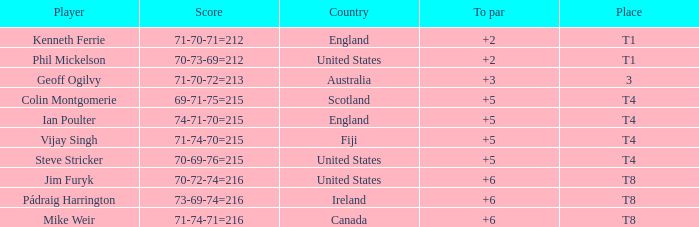What was mike weir's best score in comparison to par? 6.0. 